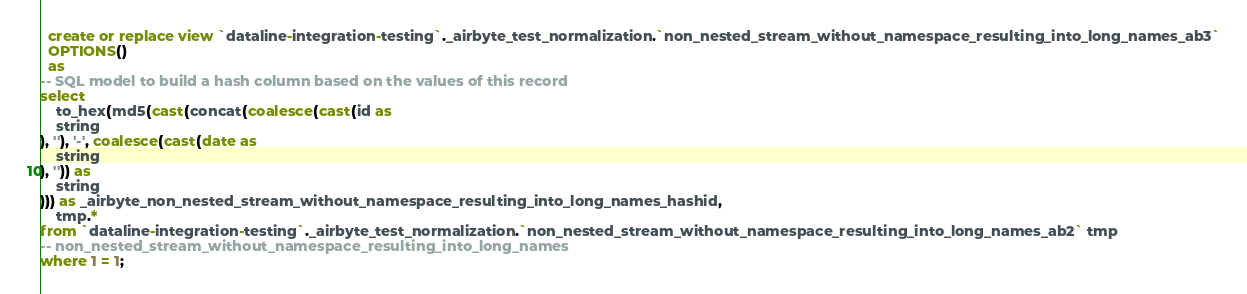Convert code to text. <code><loc_0><loc_0><loc_500><loc_500><_SQL_>

  create or replace view `dataline-integration-testing`._airbyte_test_normalization.`non_nested_stream_without_namespace_resulting_into_long_names_ab3`
  OPTIONS()
  as 
-- SQL model to build a hash column based on the values of this record
select
    to_hex(md5(cast(concat(coalesce(cast(id as 
    string
), ''), '-', coalesce(cast(date as 
    string
), '')) as 
    string
))) as _airbyte_non_nested_stream_without_namespace_resulting_into_long_names_hashid,
    tmp.*
from `dataline-integration-testing`._airbyte_test_normalization.`non_nested_stream_without_namespace_resulting_into_long_names_ab2` tmp
-- non_nested_stream_without_namespace_resulting_into_long_names
where 1 = 1;

</code> 